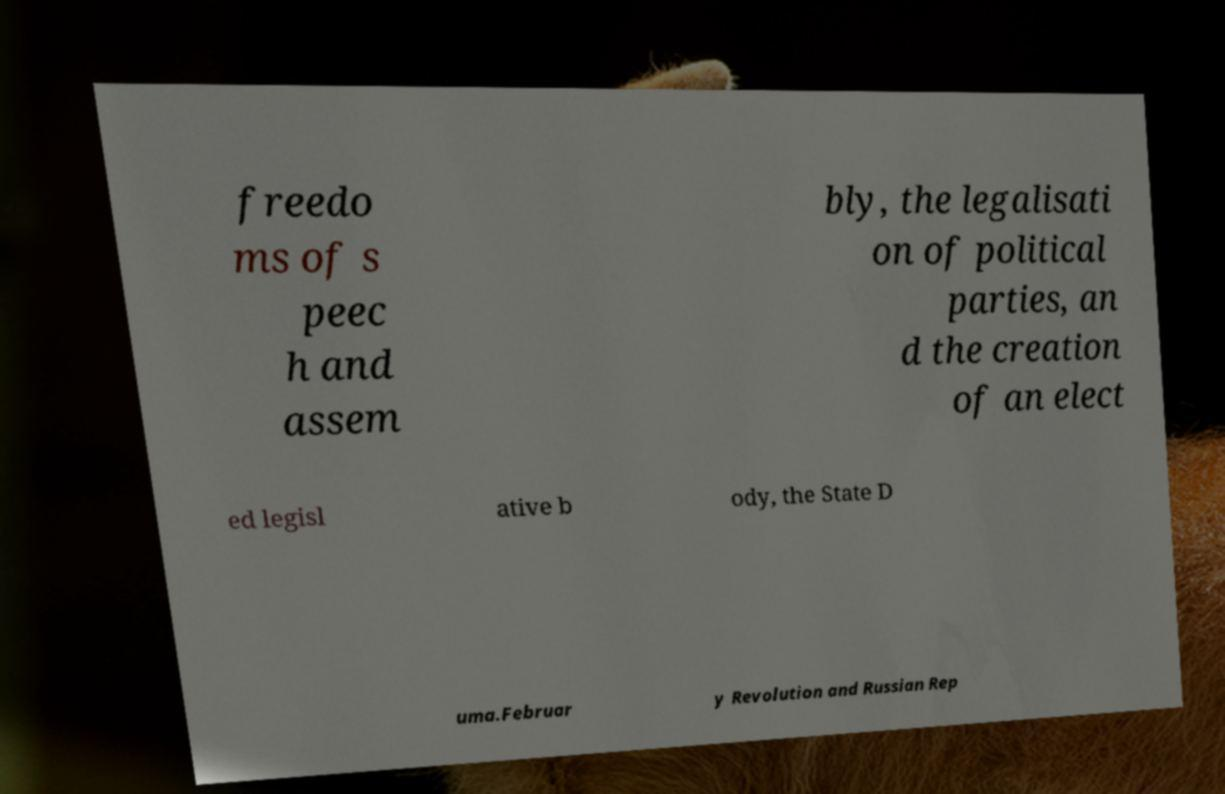There's text embedded in this image that I need extracted. Can you transcribe it verbatim? freedo ms of s peec h and assem bly, the legalisati on of political parties, an d the creation of an elect ed legisl ative b ody, the State D uma.Februar y Revolution and Russian Rep 